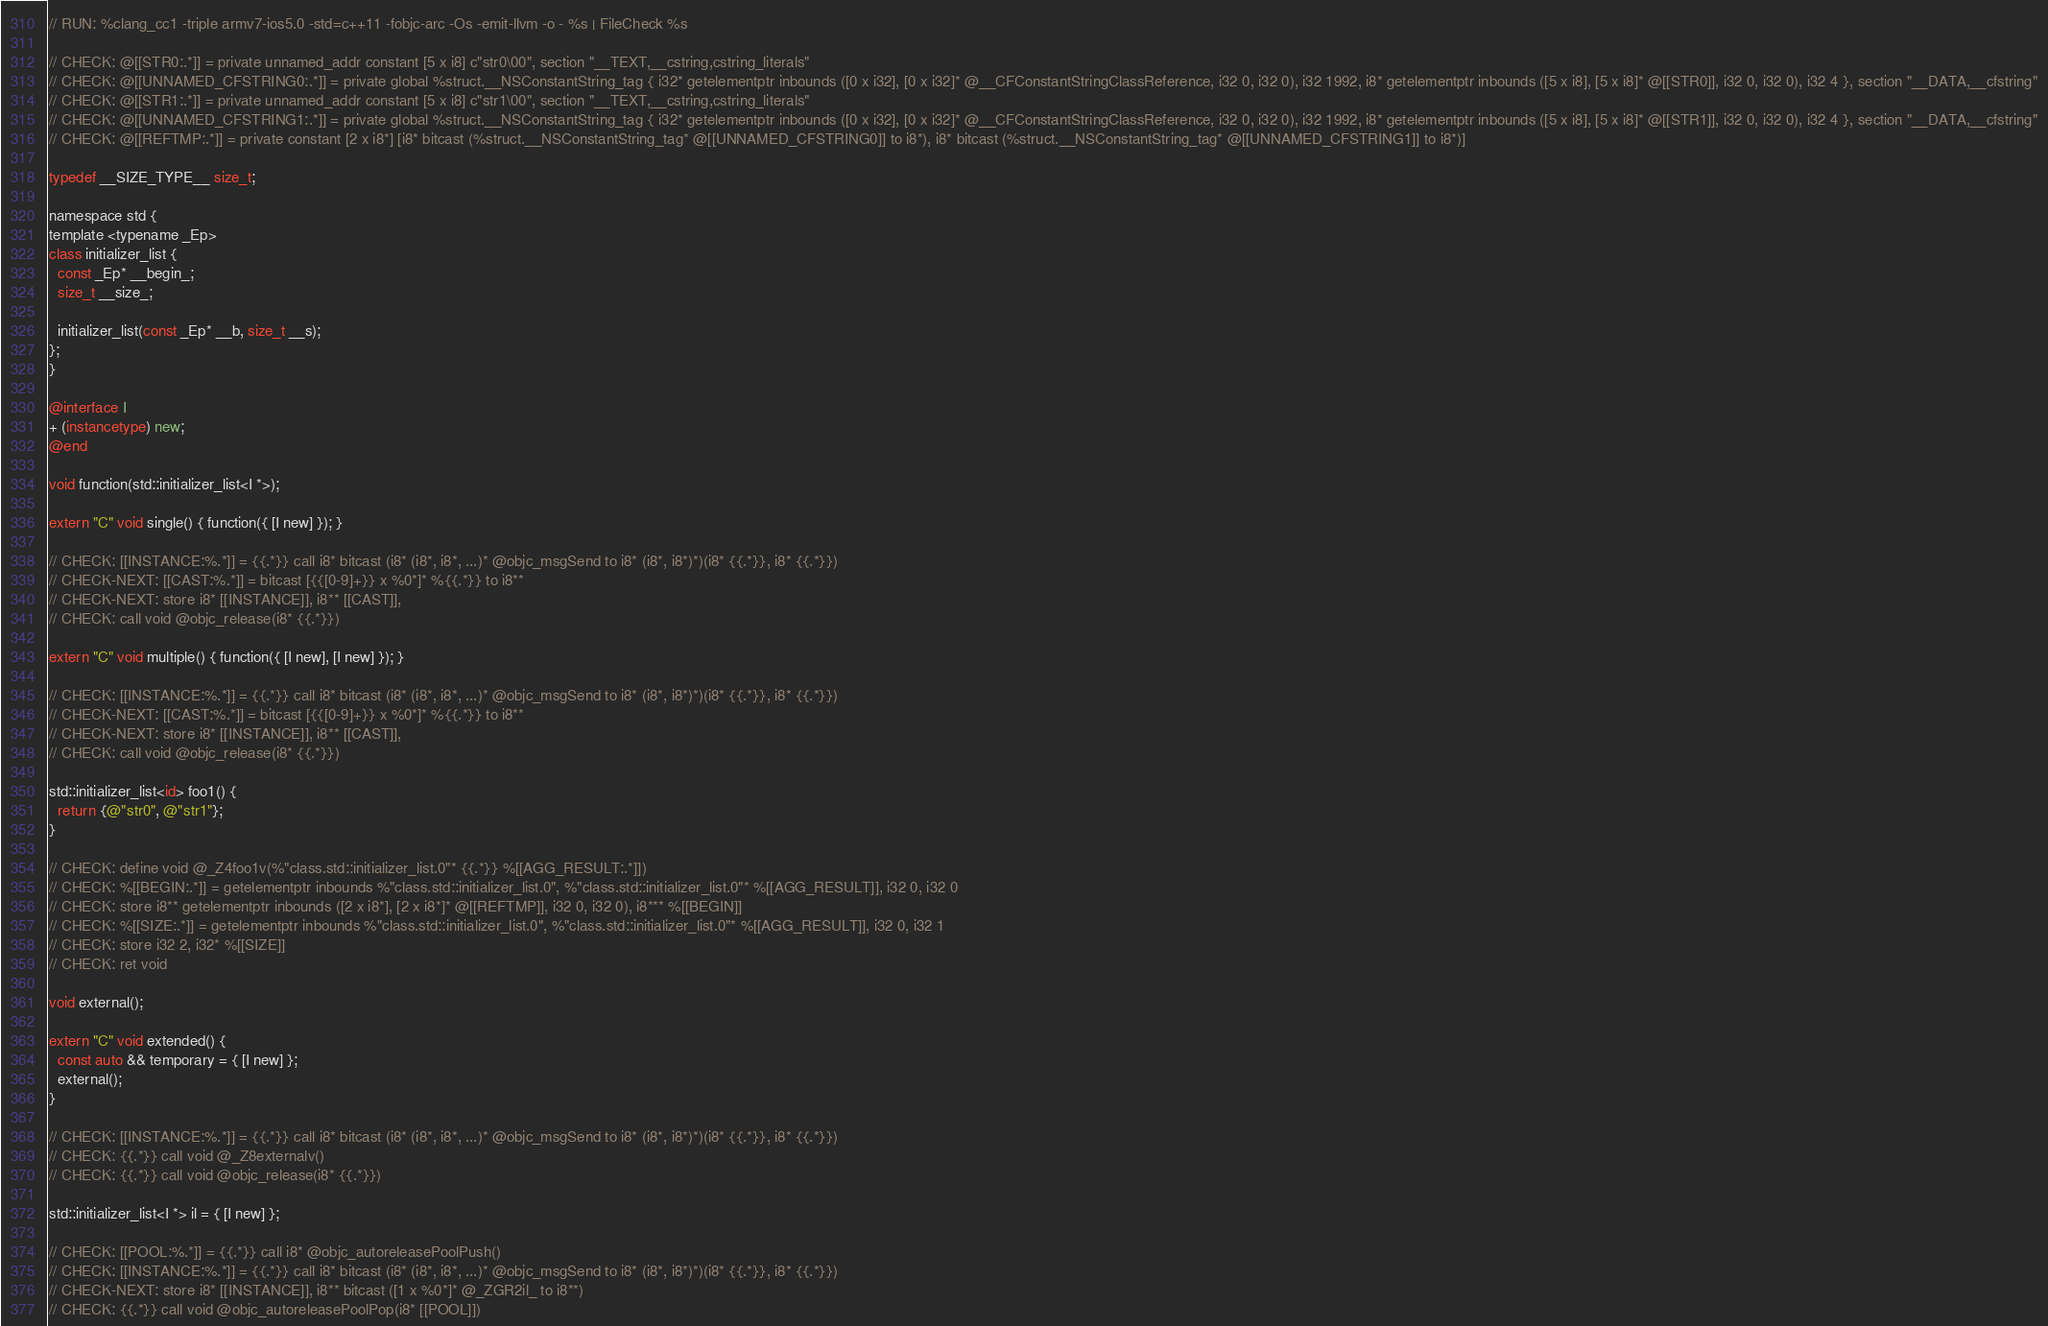<code> <loc_0><loc_0><loc_500><loc_500><_ObjectiveC_>// RUN: %clang_cc1 -triple armv7-ios5.0 -std=c++11 -fobjc-arc -Os -emit-llvm -o - %s | FileCheck %s

// CHECK: @[[STR0:.*]] = private unnamed_addr constant [5 x i8] c"str0\00", section "__TEXT,__cstring,cstring_literals"
// CHECK: @[[UNNAMED_CFSTRING0:.*]] = private global %struct.__NSConstantString_tag { i32* getelementptr inbounds ([0 x i32], [0 x i32]* @__CFConstantStringClassReference, i32 0, i32 0), i32 1992, i8* getelementptr inbounds ([5 x i8], [5 x i8]* @[[STR0]], i32 0, i32 0), i32 4 }, section "__DATA,__cfstring"
// CHECK: @[[STR1:.*]] = private unnamed_addr constant [5 x i8] c"str1\00", section "__TEXT,__cstring,cstring_literals"
// CHECK: @[[UNNAMED_CFSTRING1:.*]] = private global %struct.__NSConstantString_tag { i32* getelementptr inbounds ([0 x i32], [0 x i32]* @__CFConstantStringClassReference, i32 0, i32 0), i32 1992, i8* getelementptr inbounds ([5 x i8], [5 x i8]* @[[STR1]], i32 0, i32 0), i32 4 }, section "__DATA,__cfstring"
// CHECK: @[[REFTMP:.*]] = private constant [2 x i8*] [i8* bitcast (%struct.__NSConstantString_tag* @[[UNNAMED_CFSTRING0]] to i8*), i8* bitcast (%struct.__NSConstantString_tag* @[[UNNAMED_CFSTRING1]] to i8*)]

typedef __SIZE_TYPE__ size_t;

namespace std {
template <typename _Ep>
class initializer_list {
  const _Ep* __begin_;
  size_t __size_;

  initializer_list(const _Ep* __b, size_t __s);
};
}

@interface I
+ (instancetype) new;
@end

void function(std::initializer_list<I *>);

extern "C" void single() { function({ [I new] }); }

// CHECK: [[INSTANCE:%.*]] = {{.*}} call i8* bitcast (i8* (i8*, i8*, ...)* @objc_msgSend to i8* (i8*, i8*)*)(i8* {{.*}}, i8* {{.*}})
// CHECK-NEXT: [[CAST:%.*]] = bitcast [{{[0-9]+}} x %0*]* %{{.*}} to i8**
// CHECK-NEXT: store i8* [[INSTANCE]], i8** [[CAST]],
// CHECK: call void @objc_release(i8* {{.*}})

extern "C" void multiple() { function({ [I new], [I new] }); }

// CHECK: [[INSTANCE:%.*]] = {{.*}} call i8* bitcast (i8* (i8*, i8*, ...)* @objc_msgSend to i8* (i8*, i8*)*)(i8* {{.*}}, i8* {{.*}})
// CHECK-NEXT: [[CAST:%.*]] = bitcast [{{[0-9]+}} x %0*]* %{{.*}} to i8**
// CHECK-NEXT: store i8* [[INSTANCE]], i8** [[CAST]],
// CHECK: call void @objc_release(i8* {{.*}})

std::initializer_list<id> foo1() {
  return {@"str0", @"str1"};
}

// CHECK: define void @_Z4foo1v(%"class.std::initializer_list.0"* {{.*}} %[[AGG_RESULT:.*]])
// CHECK: %[[BEGIN:.*]] = getelementptr inbounds %"class.std::initializer_list.0", %"class.std::initializer_list.0"* %[[AGG_RESULT]], i32 0, i32 0
// CHECK: store i8** getelementptr inbounds ([2 x i8*], [2 x i8*]* @[[REFTMP]], i32 0, i32 0), i8*** %[[BEGIN]]
// CHECK: %[[SIZE:.*]] = getelementptr inbounds %"class.std::initializer_list.0", %"class.std::initializer_list.0"* %[[AGG_RESULT]], i32 0, i32 1
// CHECK: store i32 2, i32* %[[SIZE]]
// CHECK: ret void

void external();

extern "C" void extended() {
  const auto && temporary = { [I new] };
  external();
}

// CHECK: [[INSTANCE:%.*]] = {{.*}} call i8* bitcast (i8* (i8*, i8*, ...)* @objc_msgSend to i8* (i8*, i8*)*)(i8* {{.*}}, i8* {{.*}})
// CHECK: {{.*}} call void @_Z8externalv()
// CHECK: {{.*}} call void @objc_release(i8* {{.*}})

std::initializer_list<I *> il = { [I new] };

// CHECK: [[POOL:%.*]] = {{.*}} call i8* @objc_autoreleasePoolPush()
// CHECK: [[INSTANCE:%.*]] = {{.*}} call i8* bitcast (i8* (i8*, i8*, ...)* @objc_msgSend to i8* (i8*, i8*)*)(i8* {{.*}}, i8* {{.*}})
// CHECK-NEXT: store i8* [[INSTANCE]], i8** bitcast ([1 x %0*]* @_ZGR2il_ to i8**)
// CHECK: {{.*}} call void @objc_autoreleasePoolPop(i8* [[POOL]])
</code> 